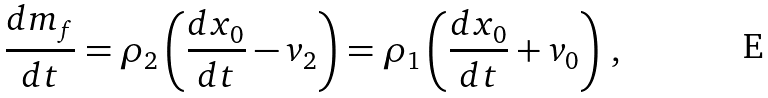Convert formula to latex. <formula><loc_0><loc_0><loc_500><loc_500>\frac { d m _ { f } } { d t } = \rho _ { 2 } \left ( \frac { d x _ { 0 } } { d t } - v _ { 2 } \right ) = \rho _ { 1 } \left ( \frac { d x _ { 0 } } { d t } + v _ { 0 } \right ) \, ,</formula> 